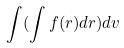<formula> <loc_0><loc_0><loc_500><loc_500>\int ( \int f ( r ) d r ) d v</formula> 